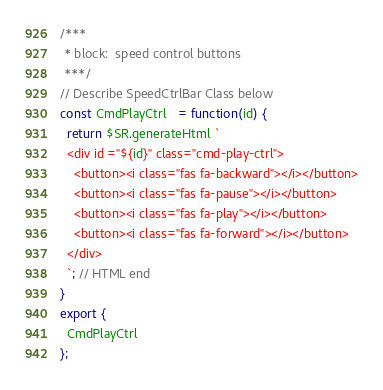Convert code to text. <code><loc_0><loc_0><loc_500><loc_500><_JavaScript_>/***
 * block:  speed control buttons
 ***/
// Describe SpeedCtrlBar Class below
const CmdPlayCtrl   = function(id) {
  return $SR.generateHtml `
  <div id ="${id}" class="cmd-play-ctrl">
    <button><i class="fas fa-backward"></i></button>
    <button><i class="fas fa-pause"></i></button>
    <button><i class="fas fa-play"></i></button>
    <button><i class="fas fa-forward"></i></button>
  </div>
  `; // HTML end
}
export {
  CmdPlayCtrl
};
</code> 